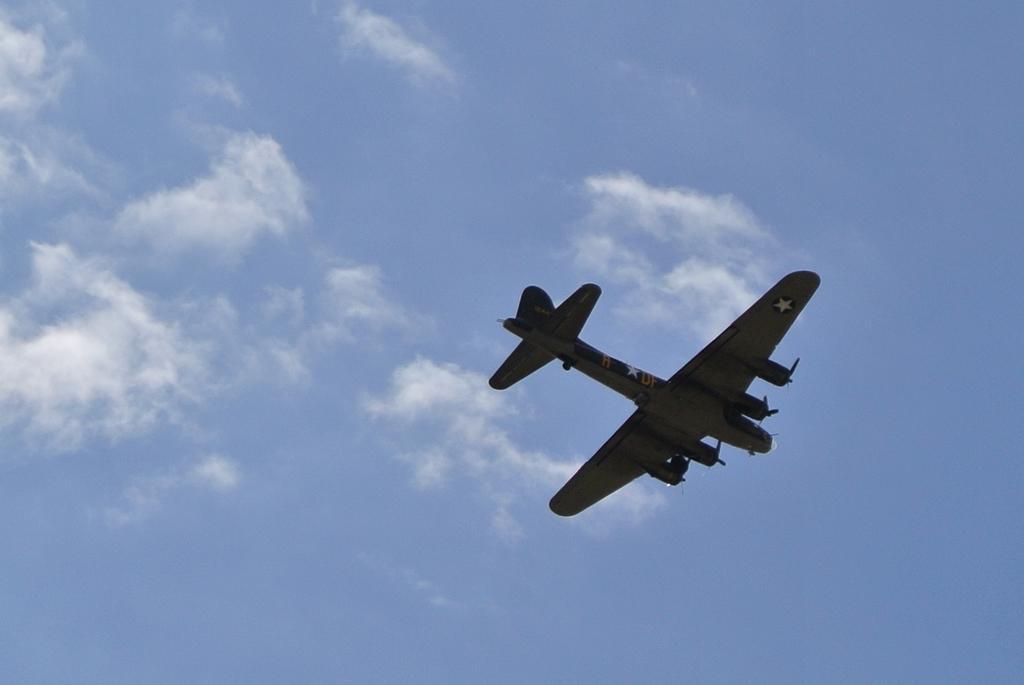Describe this image in one or two sentences. In the picture I can see an aircraft flying in the sky. There are clouds in the sky. 